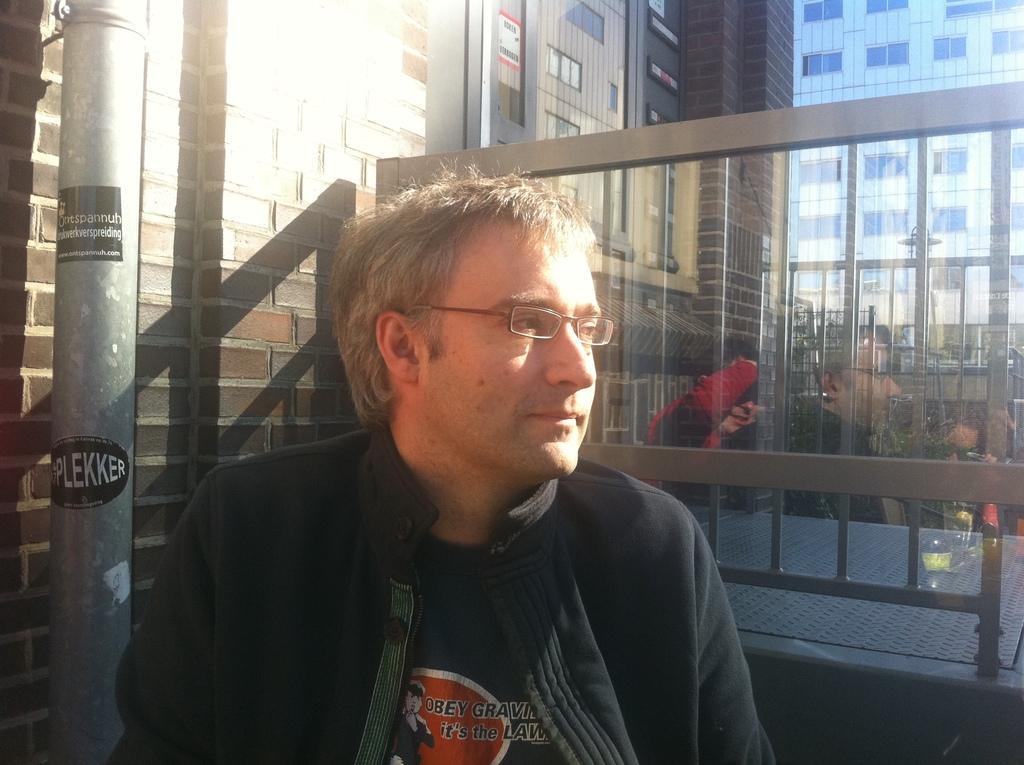Can you describe this image briefly? In this image in front there is a person. Beside him there is a pole. Behind him there is a metal fence. In the background of the image there are buildings. On the left side of the image there is a wall. 